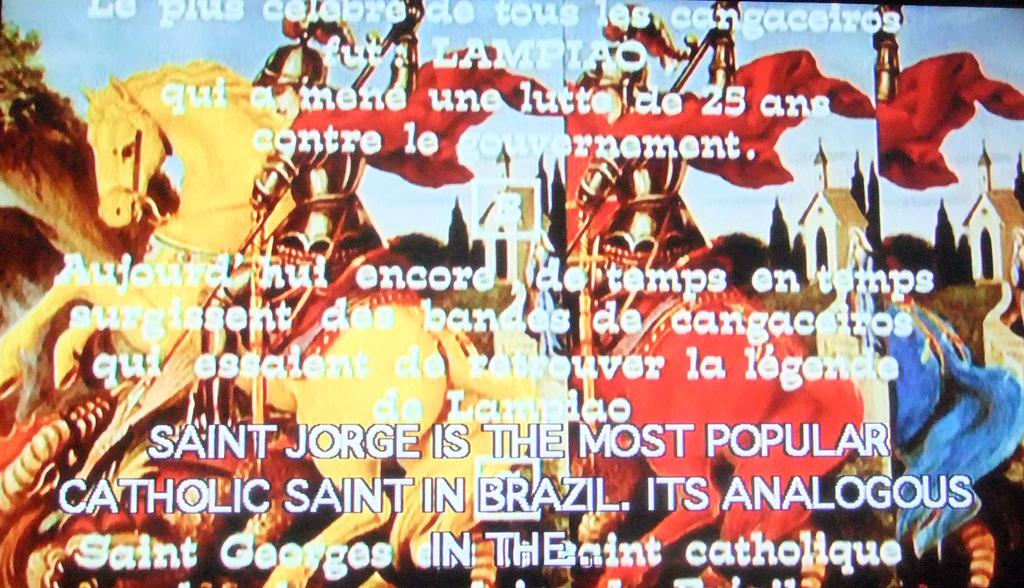Provide a one-sentence caption for the provided image. A bright colored page of some sort talkink about Saint George. 